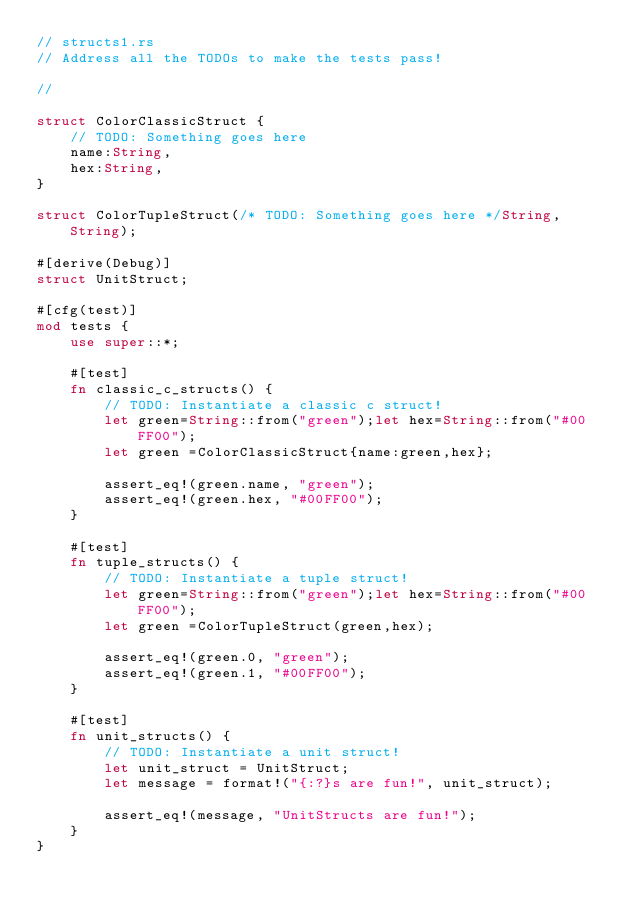<code> <loc_0><loc_0><loc_500><loc_500><_Rust_>// structs1.rs
// Address all the TODOs to make the tests pass!

//

struct ColorClassicStruct {
    // TODO: Something goes here
    name:String,
    hex:String,
}

struct ColorTupleStruct(/* TODO: Something goes here */String,String);

#[derive(Debug)]
struct UnitStruct;

#[cfg(test)]
mod tests {
    use super::*;

    #[test]
    fn classic_c_structs() {
        // TODO: Instantiate a classic c struct!
        let green=String::from("green");let hex=String::from("#00FF00");
        let green =ColorClassicStruct{name:green,hex};

        assert_eq!(green.name, "green");
        assert_eq!(green.hex, "#00FF00");
    }

    #[test]
    fn tuple_structs() {
        // TODO: Instantiate a tuple struct!
        let green=String::from("green");let hex=String::from("#00FF00");
        let green =ColorTupleStruct(green,hex);

        assert_eq!(green.0, "green");
        assert_eq!(green.1, "#00FF00");
    }

    #[test]
    fn unit_structs() {
        // TODO: Instantiate a unit struct!
        let unit_struct = UnitStruct;
        let message = format!("{:?}s are fun!", unit_struct);

        assert_eq!(message, "UnitStructs are fun!");
    }
}
</code> 